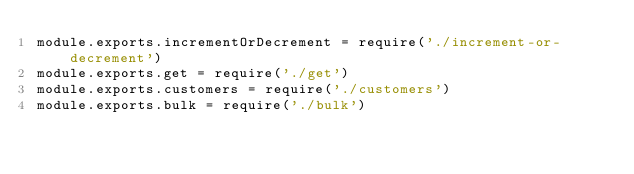Convert code to text. <code><loc_0><loc_0><loc_500><loc_500><_JavaScript_>module.exports.incrementOrDecrement = require('./increment-or-decrement')
module.exports.get = require('./get')
module.exports.customers = require('./customers')
module.exports.bulk = require('./bulk')
</code> 